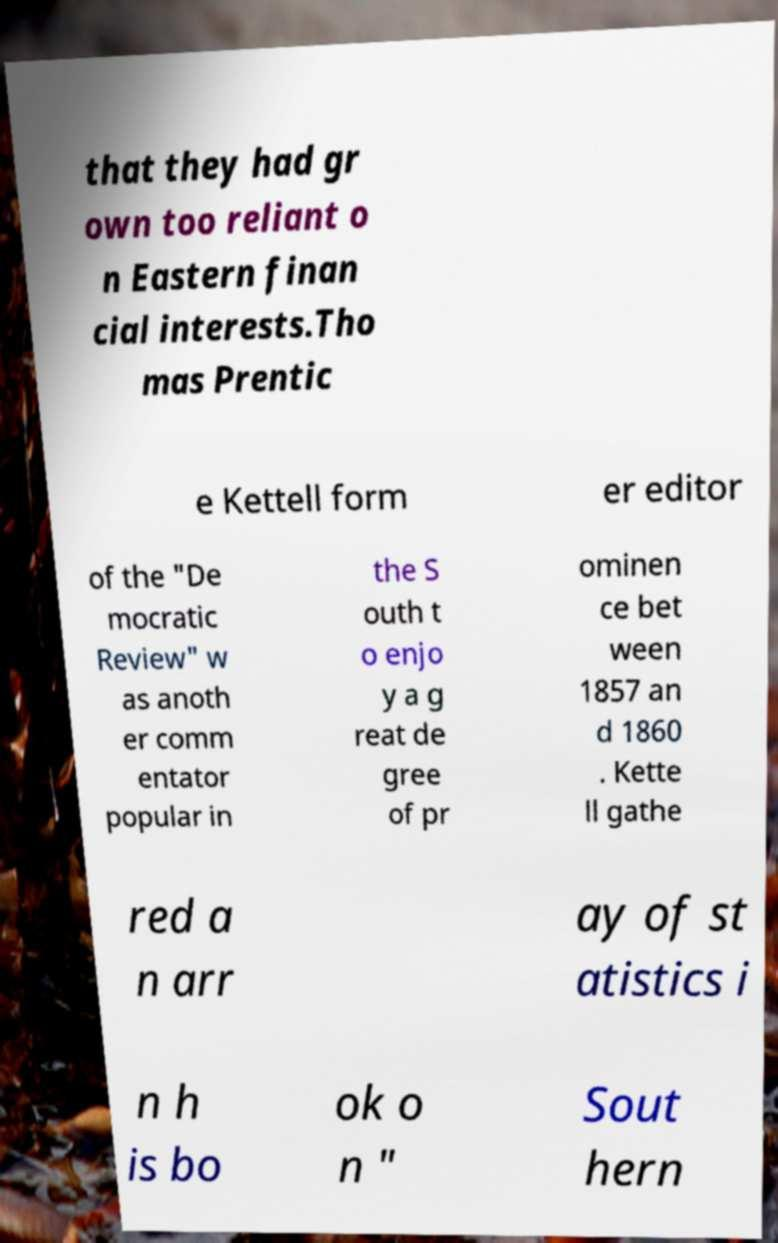Please identify and transcribe the text found in this image. that they had gr own too reliant o n Eastern finan cial interests.Tho mas Prentic e Kettell form er editor of the "De mocratic Review" w as anoth er comm entator popular in the S outh t o enjo y a g reat de gree of pr ominen ce bet ween 1857 an d 1860 . Kette ll gathe red a n arr ay of st atistics i n h is bo ok o n " Sout hern 